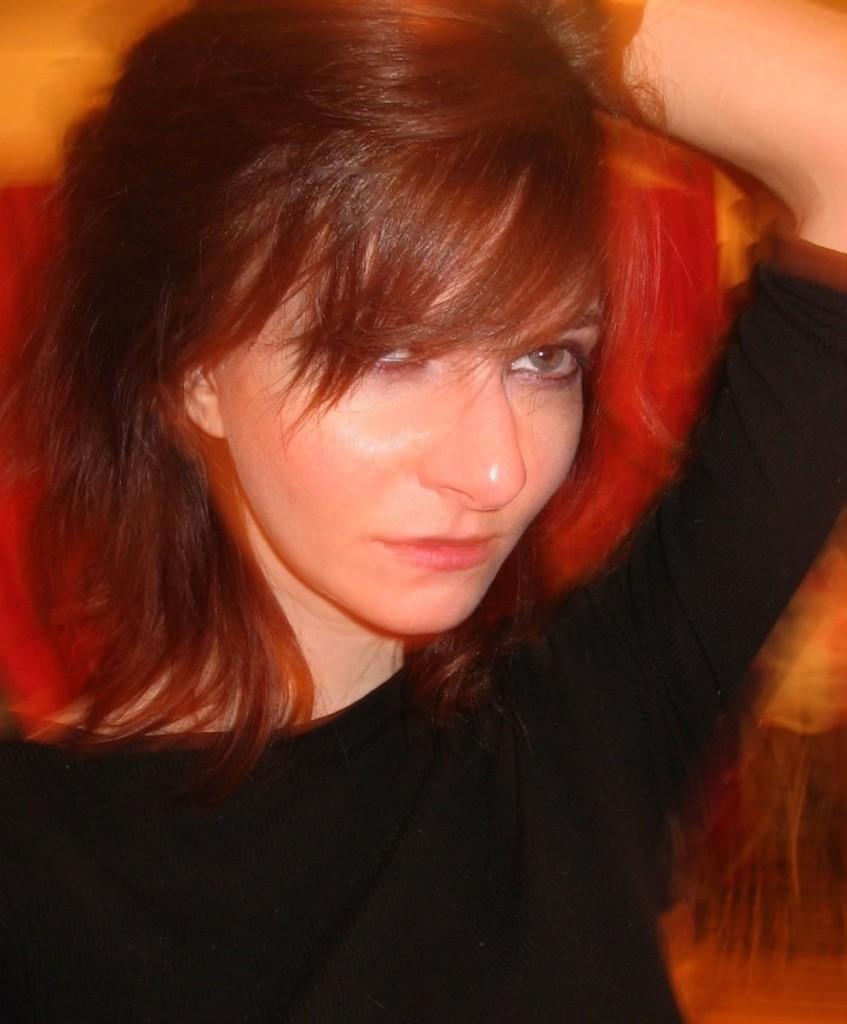Could you give a brief overview of what you see in this image? In this image we can see a lady wearing a black dress. 